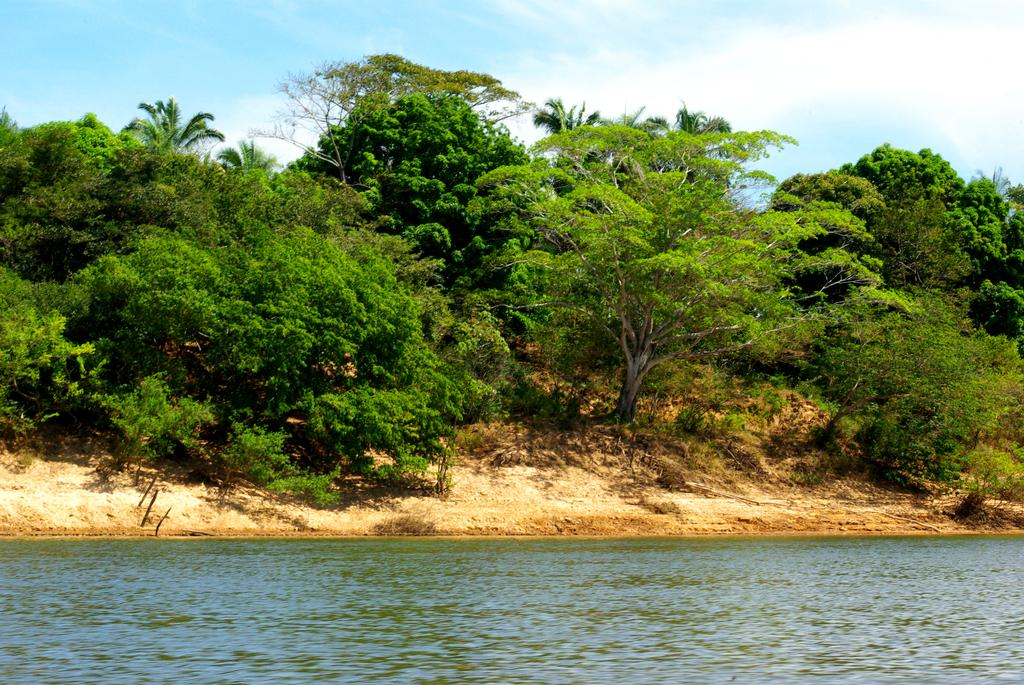What is the primary element in the image? The image consists of water. What can be seen in the background of the image? There are many trees in the background. What is visible in the sky at the top of the image? There are clouds in the sky at the top of the image. What type of order is being followed by the icicles in the image? There are no icicles present in the image, so it is not possible to determine if any order is being followed. 